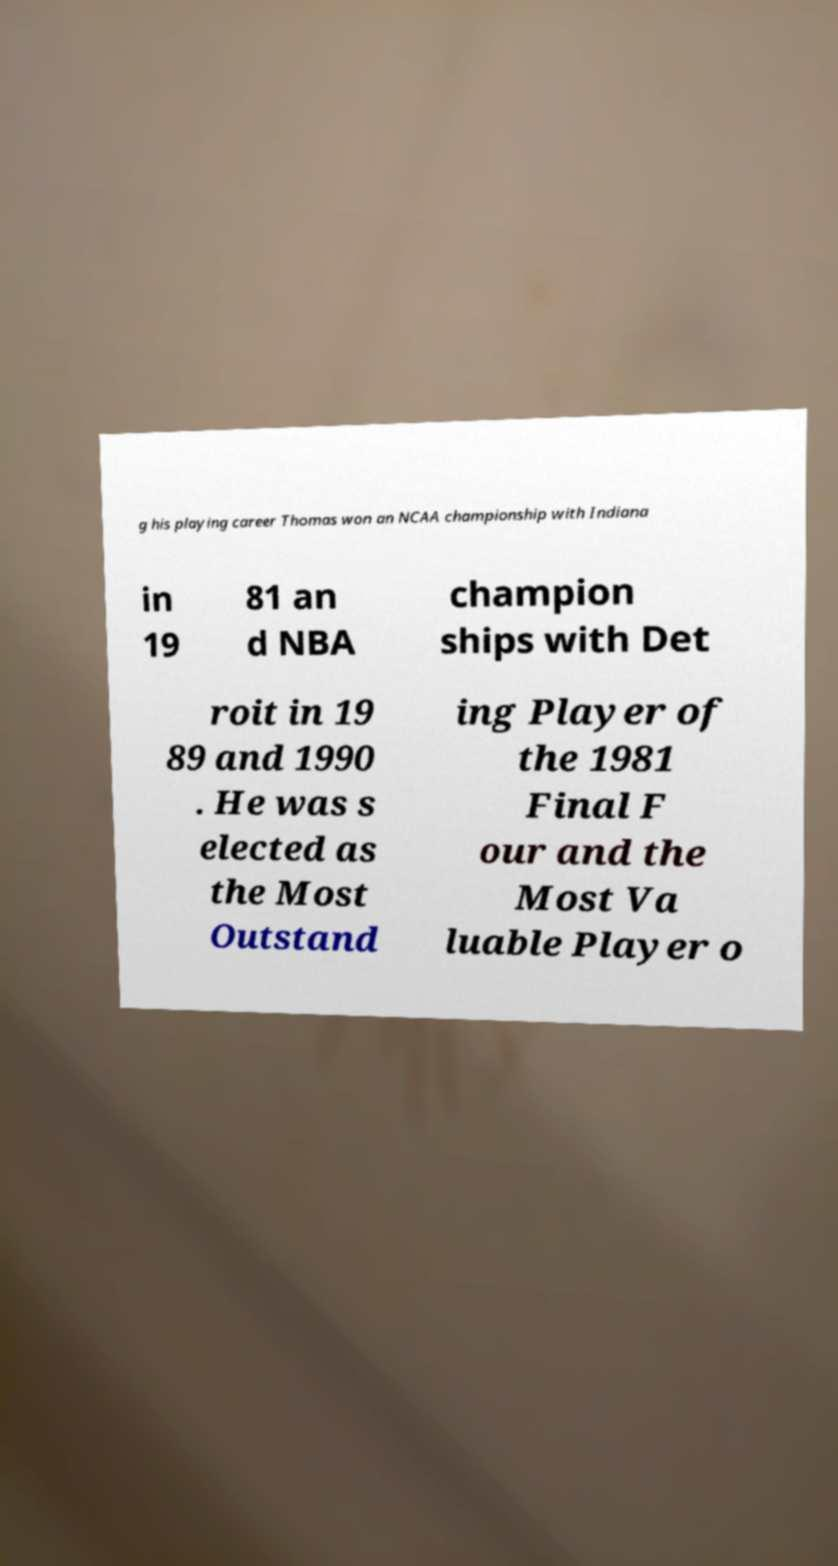For documentation purposes, I need the text within this image transcribed. Could you provide that? g his playing career Thomas won an NCAA championship with Indiana in 19 81 an d NBA champion ships with Det roit in 19 89 and 1990 . He was s elected as the Most Outstand ing Player of the 1981 Final F our and the Most Va luable Player o 